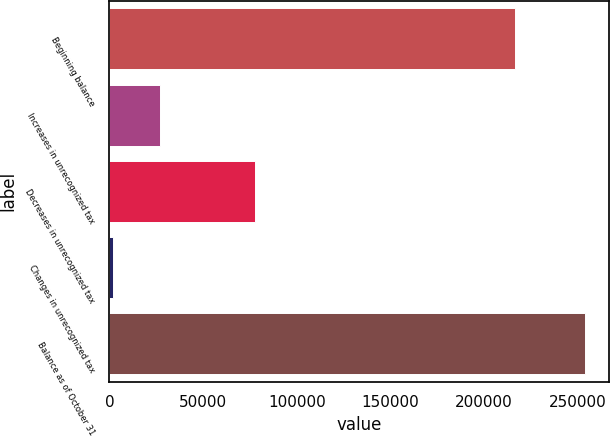<chart> <loc_0><loc_0><loc_500><loc_500><bar_chart><fcel>Beginning balance<fcel>Increases in unrecognized tax<fcel>Decreases in unrecognized tax<fcel>Changes in unrecognized tax<fcel>Balance as of October 31<nl><fcel>216627<fcel>27205<fcel>77573<fcel>2021<fcel>253861<nl></chart> 